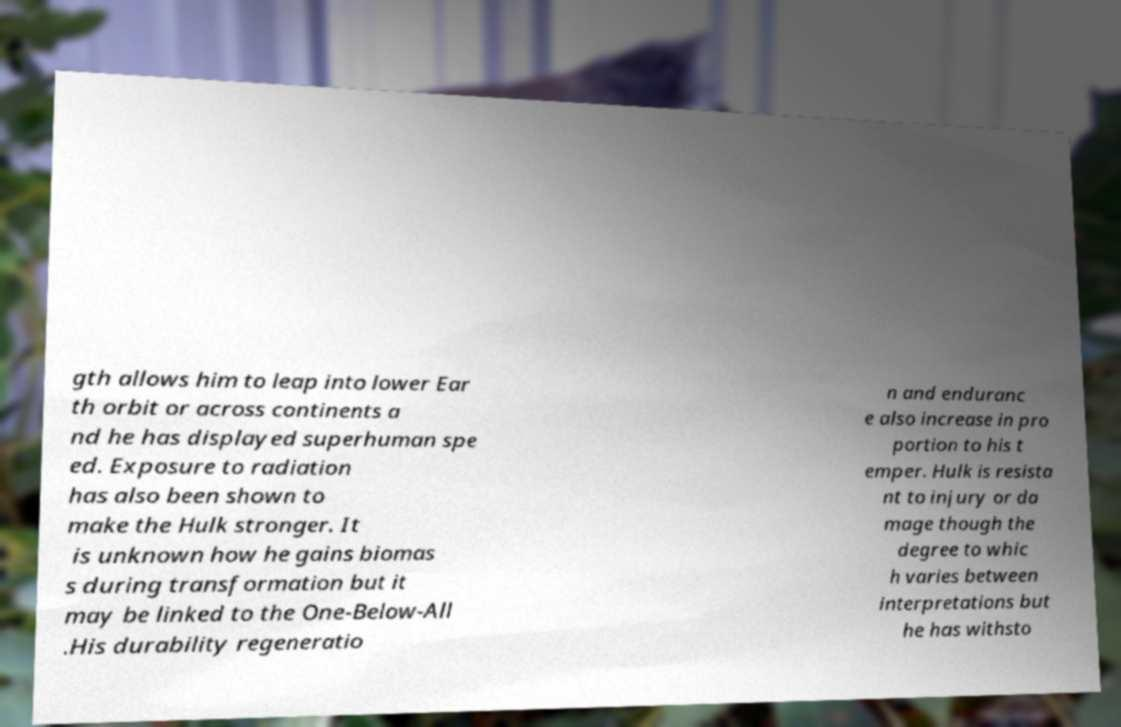Can you accurately transcribe the text from the provided image for me? gth allows him to leap into lower Ear th orbit or across continents a nd he has displayed superhuman spe ed. Exposure to radiation has also been shown to make the Hulk stronger. It is unknown how he gains biomas s during transformation but it may be linked to the One-Below-All .His durability regeneratio n and enduranc e also increase in pro portion to his t emper. Hulk is resista nt to injury or da mage though the degree to whic h varies between interpretations but he has withsto 